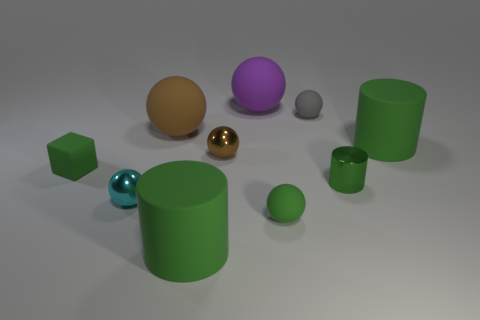How would you describe the positions of the objects relative to each other? The arrangement of the objects on the flat surface suggests a casually scattered layout, without a precise or orderly placement. Starting from the foreground, a small green cube and the glossy turquoise sphere are close to each other; the sphere has a slightly forward position. Moving to the middle, the shiny gold sphere is somewhat centrally located with ample space around it. Towards the back, the large green cylinder, the small gray sphere, and a small green cylinder are in close proximity, forming an informal group. The purple sphere occupies a space towards the right side of the image, slightly isolated from the other objects. 